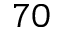<formula> <loc_0><loc_0><loc_500><loc_500>^ { 7 0 }</formula> 